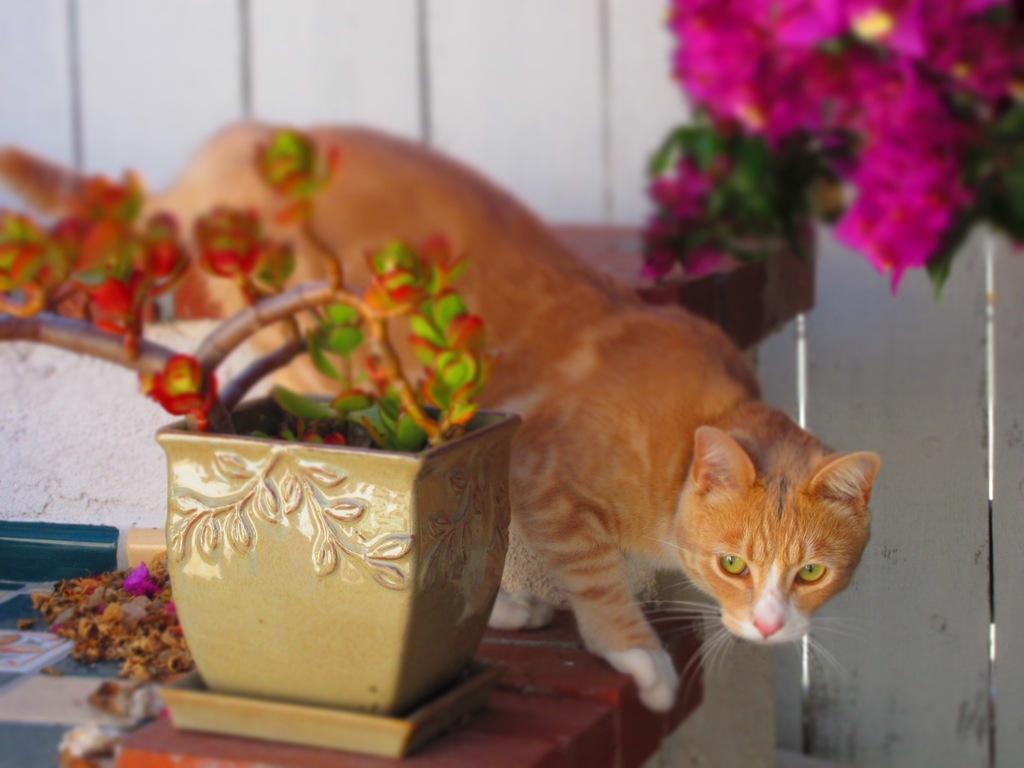Describe this image in one or two sentences. In this image there is a cat on the table. Beside the cat there is a flower pot and there are some other objects. Behind the cat there is a table. There is a wall. On the right side of the image there are flowers and leaves. 